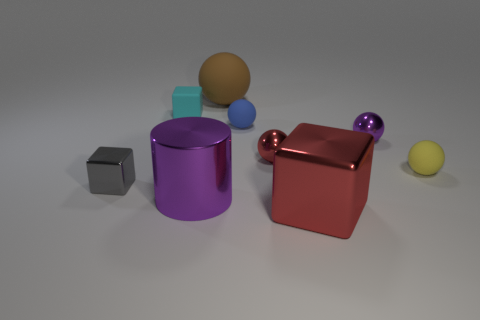Subtract 1 blocks. How many blocks are left? 2 Subtract all yellow balls. How many balls are left? 4 Subtract all large rubber balls. How many balls are left? 4 Add 1 tiny cyan things. How many objects exist? 10 Subtract all yellow spheres. Subtract all yellow blocks. How many spheres are left? 4 Subtract all blocks. How many objects are left? 6 Subtract all small purple things. Subtract all spheres. How many objects are left? 3 Add 3 tiny balls. How many tiny balls are left? 7 Add 8 metal blocks. How many metal blocks exist? 10 Subtract 0 green blocks. How many objects are left? 9 